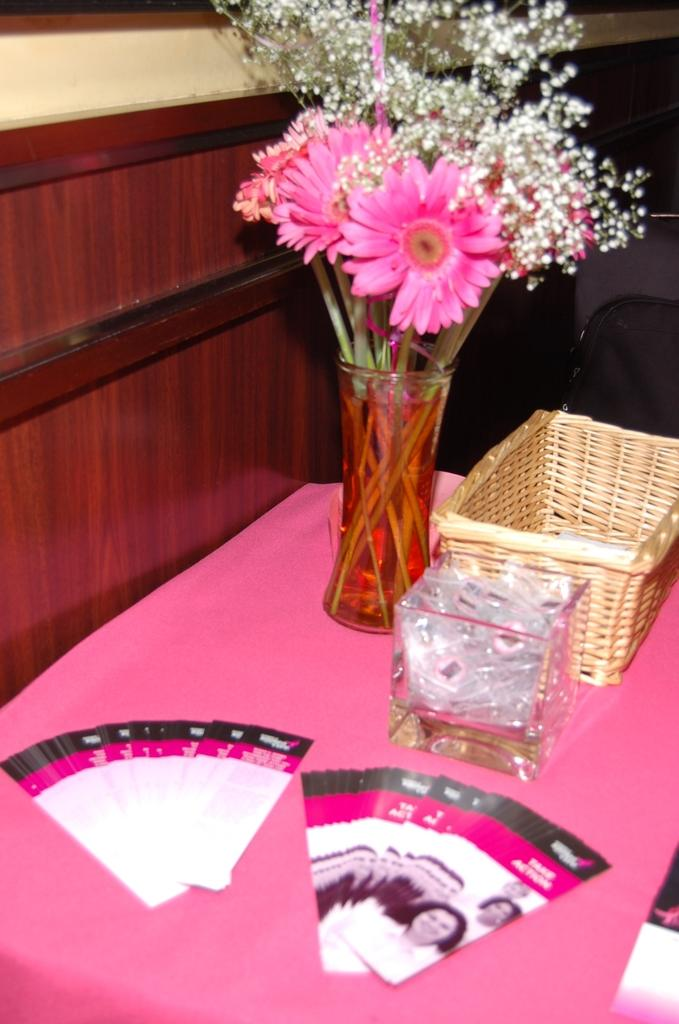What type of furniture is present in the image? There is a table in the image. What is placed on the table? There is a flower bouquet on the table. Are there any other objects on the table besides the flower bouquet? Yes, there are other objects on the table. What type of riddle is being solved by the cloud in the image? There is no cloud present in the image, and therefore no riddle-solving activity can be observed. 